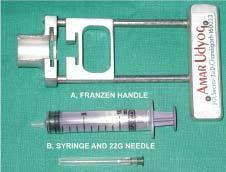what is required for transcutaneous fnac?
Answer the question using a single word or phrase. Equipments 